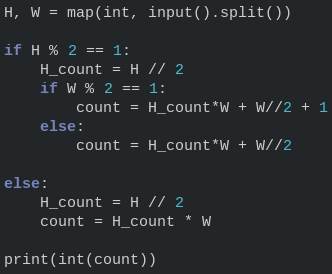<code> <loc_0><loc_0><loc_500><loc_500><_Python_>H, W = map(int, input().split())

if H % 2 == 1:
    H_count = H // 2
    if W % 2 == 1:
        count = H_count*W + W//2 + 1
    else:
        count = H_count*W + W//2

else:
    H_count = H // 2
    count = H_count * W

print(int(count))</code> 